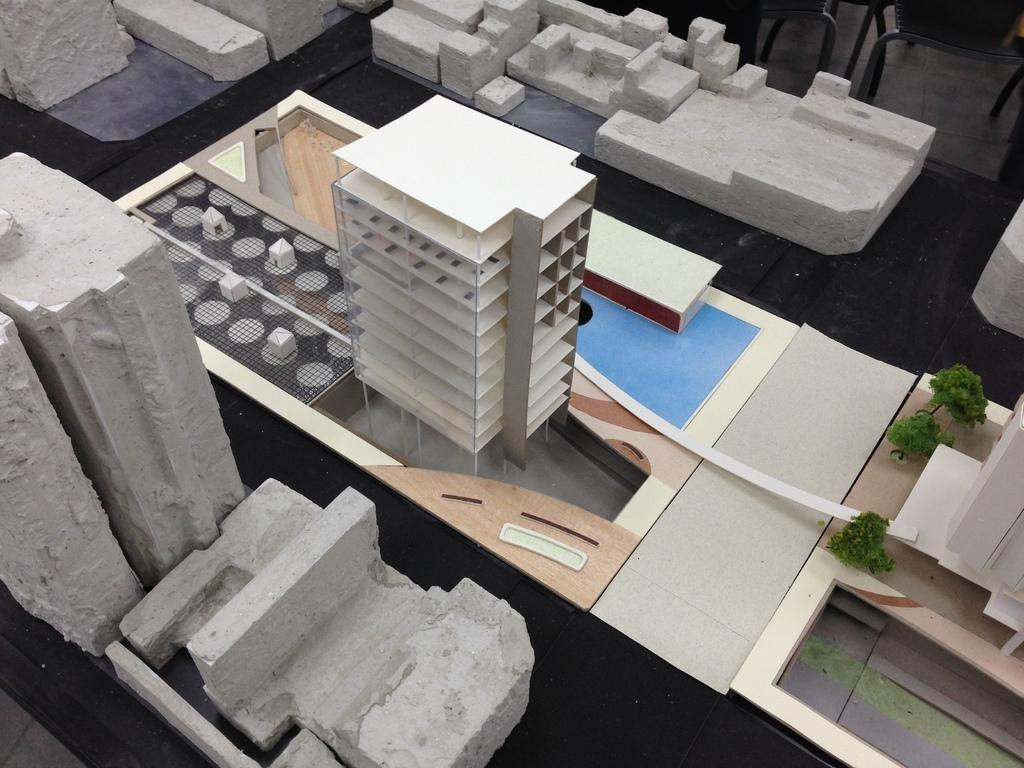What is the main subject of the image? The main subject of the image is a small architecture model of a building. Are there any other elements present in the image? Yes, there are stones visible in the image. How many bags of popcorn are placed near the architecture model in the image? There is no popcorn present in the image. What type of sack is used to carry the architecture model in the image? There is no sack present in the image; the architecture model is stationary. 